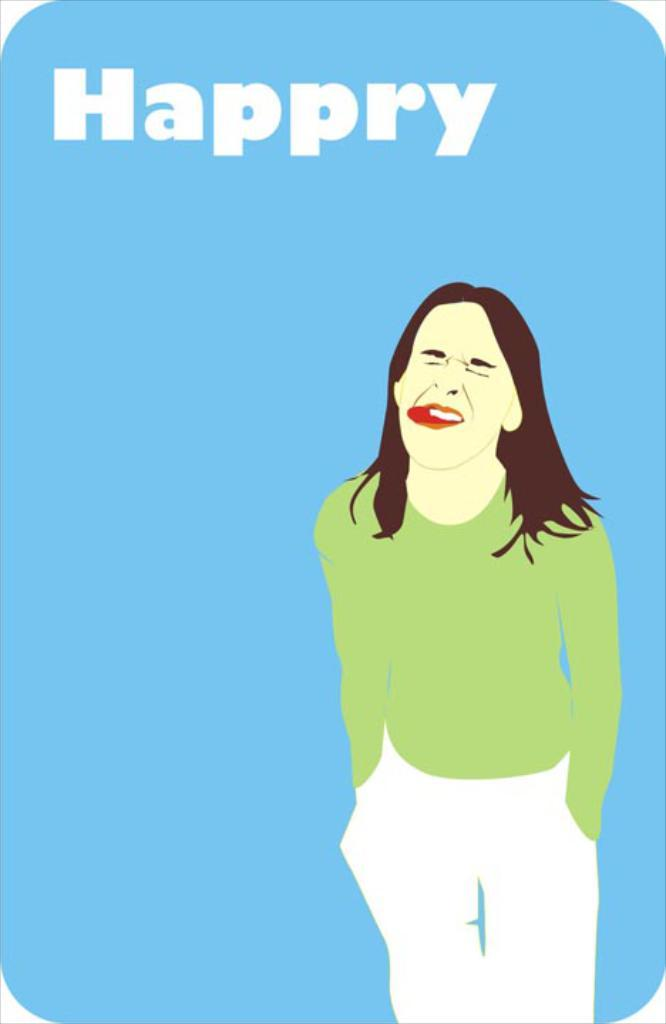Provide a one-sentence caption for the provided image. The woman has her tongue stuck out and the misspelling of happy is on the photo. 